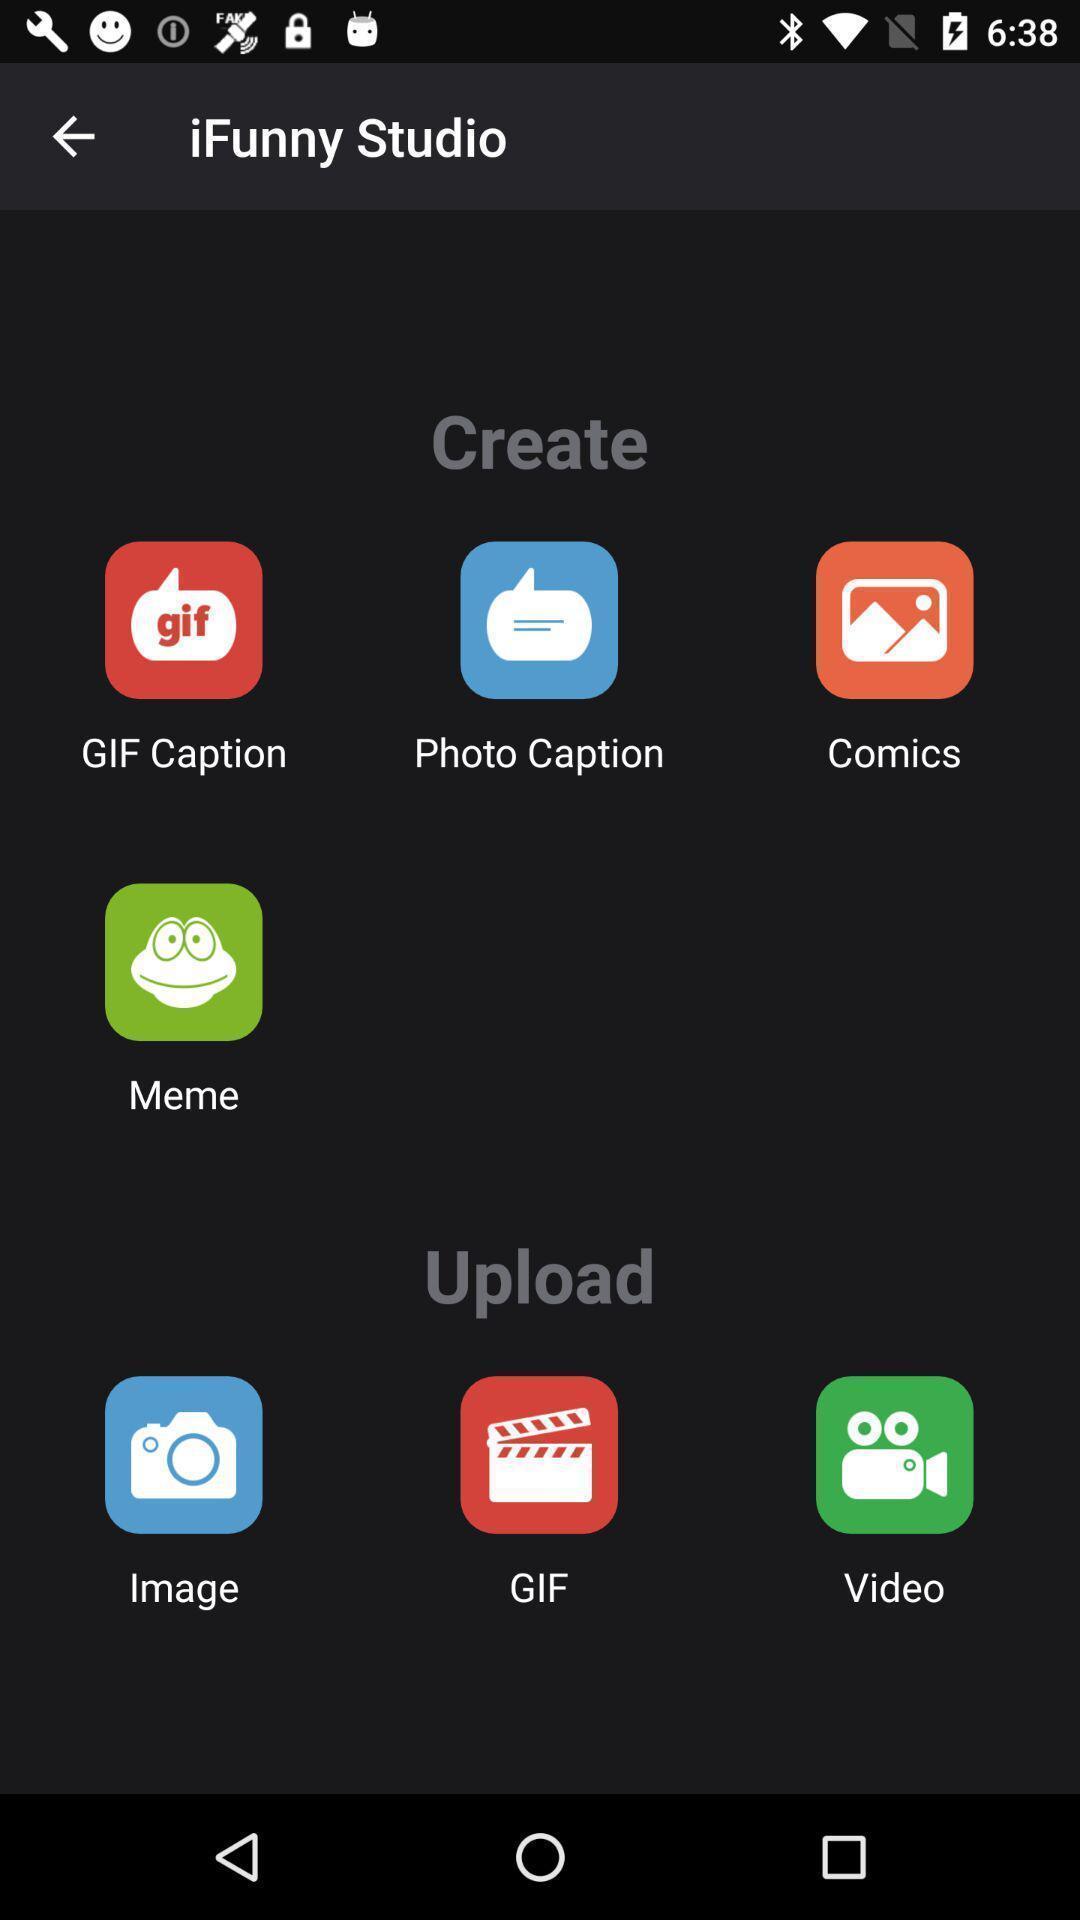What can you discern from this picture? Welcome page with various options. 